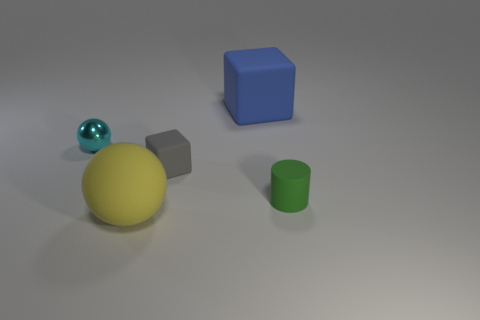Add 1 large cyan shiny cylinders. How many objects exist? 6 Subtract 1 yellow spheres. How many objects are left? 4 Subtract all balls. How many objects are left? 3 Subtract all red rubber objects. Subtract all yellow things. How many objects are left? 4 Add 4 small green things. How many small green things are left? 5 Add 2 large blocks. How many large blocks exist? 3 